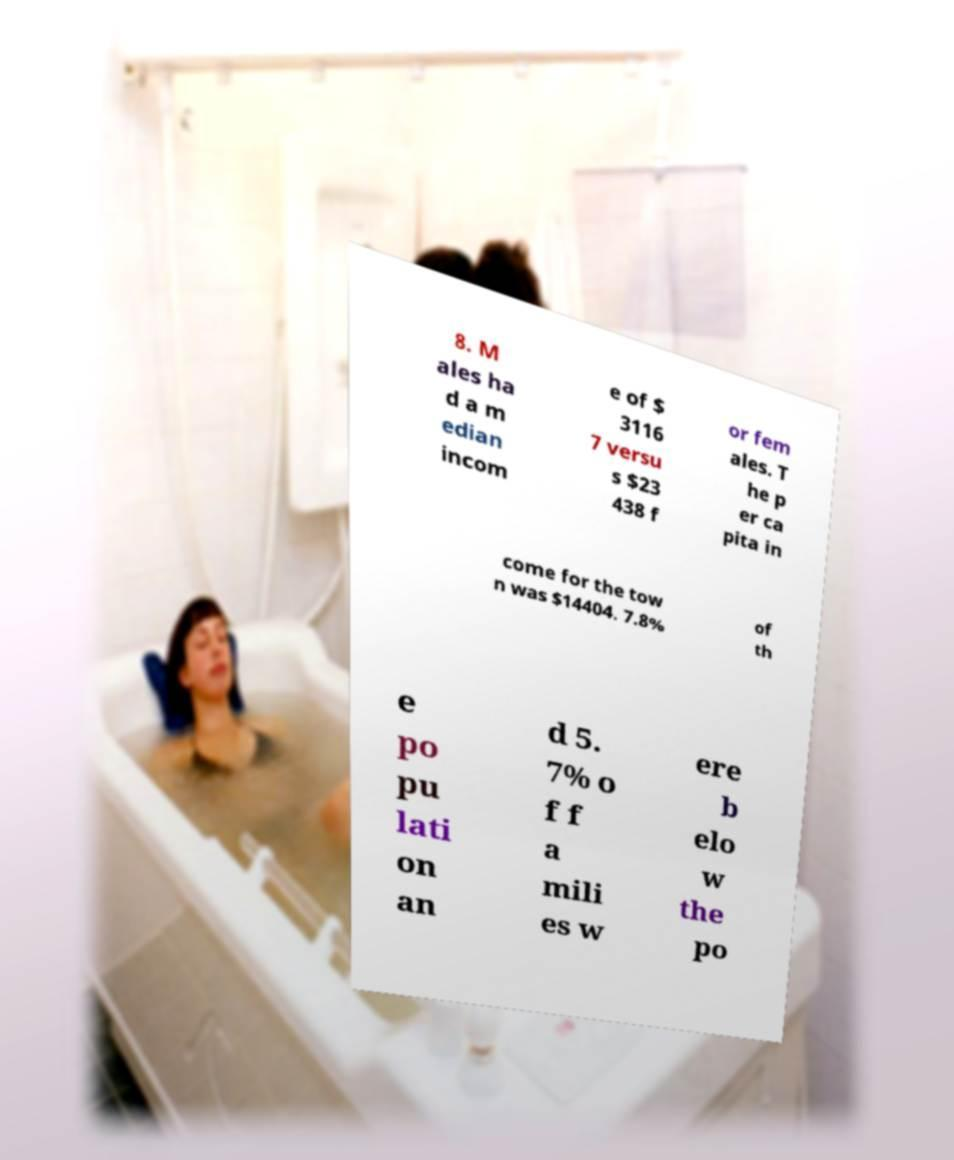There's text embedded in this image that I need extracted. Can you transcribe it verbatim? 8. M ales ha d a m edian incom e of $ 3116 7 versu s $23 438 f or fem ales. T he p er ca pita in come for the tow n was $14404. 7.8% of th e po pu lati on an d 5. 7% o f f a mili es w ere b elo w the po 